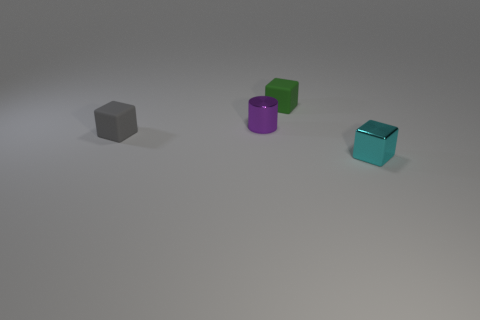What does the color variety of these objects tell you about the creator's intent? The use of varied colors, including a neutral gray and more vibrant hues, may hint at the creator's intent to juxtapose the mundane with the lively. It suggests an exploration of how color impacts perception and can be used to give character and vibrancy to otherwise simple forms. 